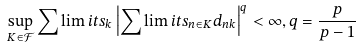<formula> <loc_0><loc_0><loc_500><loc_500>\sup _ { K \in \mathcal { F } } \sum \lim i t s _ { k } \left | \sum \lim i t s _ { n \in K } d _ { n k } \right | ^ { q } < \infty , q = \frac { p } { p - 1 }</formula> 